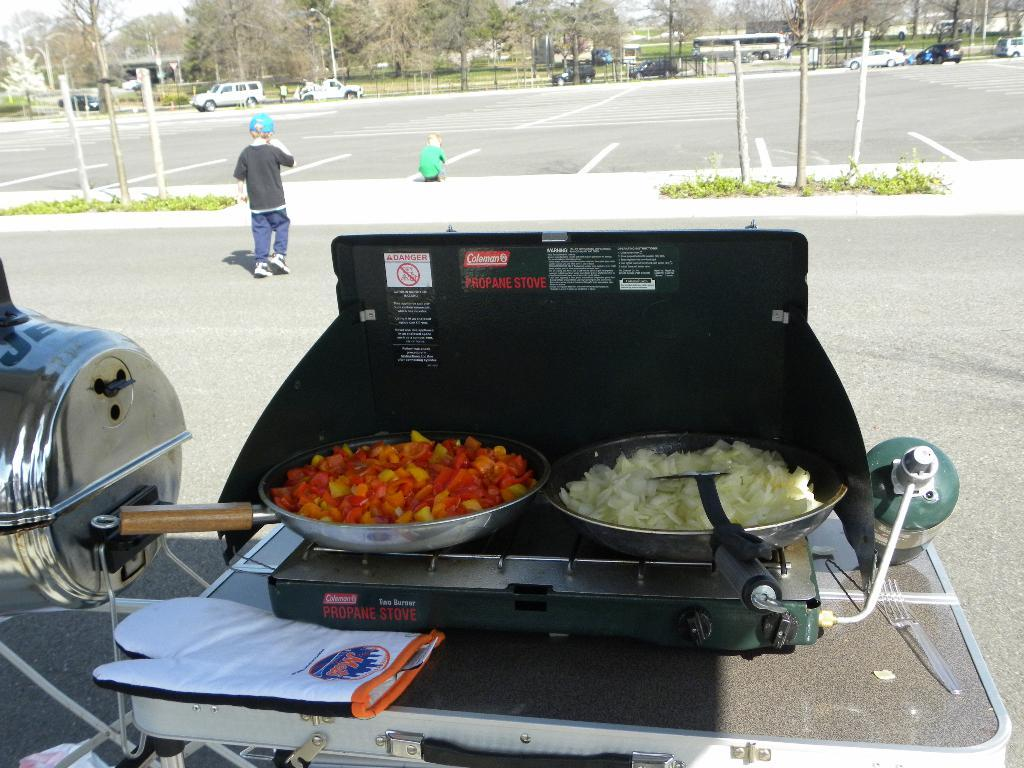<image>
Write a terse but informative summary of the picture. Two pans of various vegetables are being sauted on a Coleman portable gas grill. 